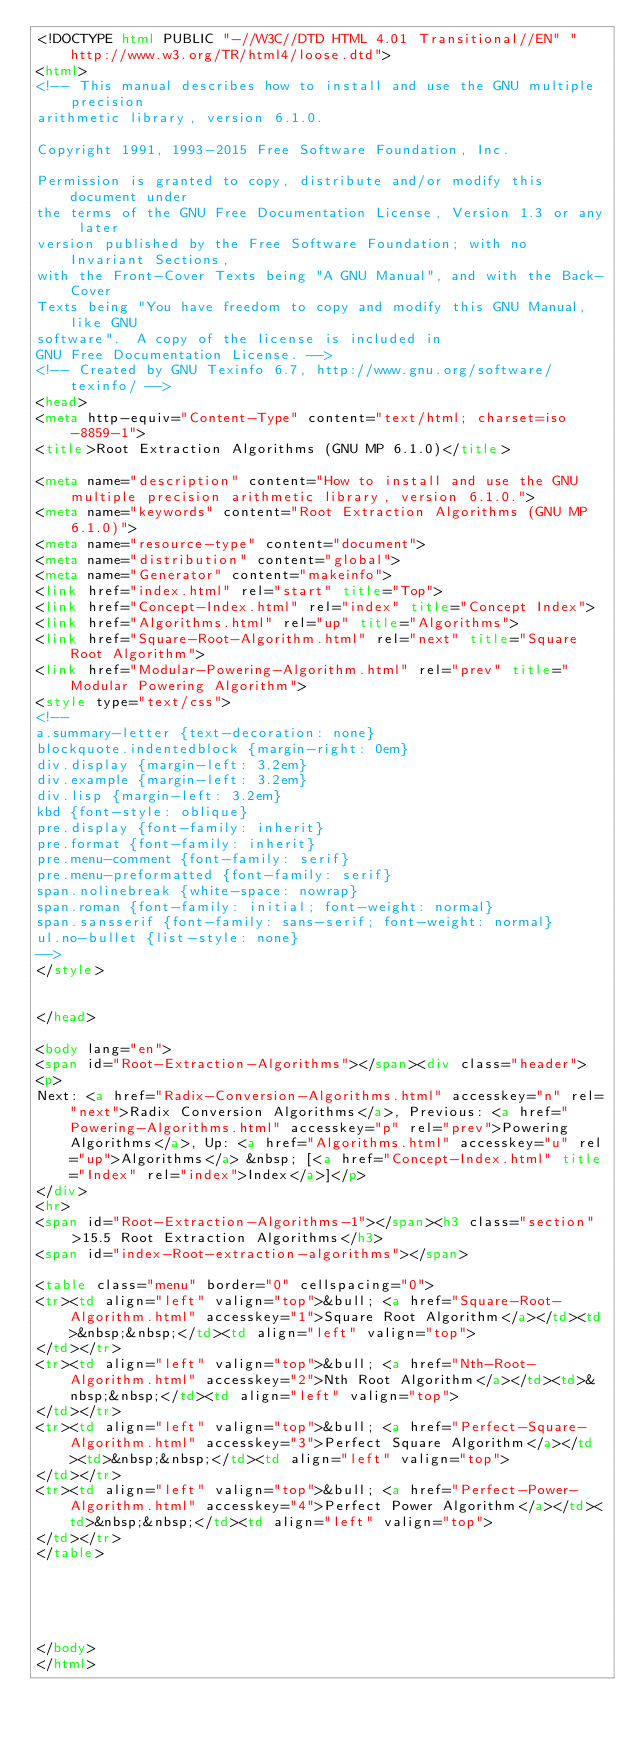<code> <loc_0><loc_0><loc_500><loc_500><_HTML_><!DOCTYPE html PUBLIC "-//W3C//DTD HTML 4.01 Transitional//EN" "http://www.w3.org/TR/html4/loose.dtd">
<html>
<!-- This manual describes how to install and use the GNU multiple precision
arithmetic library, version 6.1.0.

Copyright 1991, 1993-2015 Free Software Foundation, Inc.

Permission is granted to copy, distribute and/or modify this document under
the terms of the GNU Free Documentation License, Version 1.3 or any later
version published by the Free Software Foundation; with no Invariant Sections,
with the Front-Cover Texts being "A GNU Manual", and with the Back-Cover
Texts being "You have freedom to copy and modify this GNU Manual, like GNU
software".  A copy of the license is included in
GNU Free Documentation License. -->
<!-- Created by GNU Texinfo 6.7, http://www.gnu.org/software/texinfo/ -->
<head>
<meta http-equiv="Content-Type" content="text/html; charset=iso-8859-1">
<title>Root Extraction Algorithms (GNU MP 6.1.0)</title>

<meta name="description" content="How to install and use the GNU multiple precision arithmetic library, version 6.1.0.">
<meta name="keywords" content="Root Extraction Algorithms (GNU MP 6.1.0)">
<meta name="resource-type" content="document">
<meta name="distribution" content="global">
<meta name="Generator" content="makeinfo">
<link href="index.html" rel="start" title="Top">
<link href="Concept-Index.html" rel="index" title="Concept Index">
<link href="Algorithms.html" rel="up" title="Algorithms">
<link href="Square-Root-Algorithm.html" rel="next" title="Square Root Algorithm">
<link href="Modular-Powering-Algorithm.html" rel="prev" title="Modular Powering Algorithm">
<style type="text/css">
<!--
a.summary-letter {text-decoration: none}
blockquote.indentedblock {margin-right: 0em}
div.display {margin-left: 3.2em}
div.example {margin-left: 3.2em}
div.lisp {margin-left: 3.2em}
kbd {font-style: oblique}
pre.display {font-family: inherit}
pre.format {font-family: inherit}
pre.menu-comment {font-family: serif}
pre.menu-preformatted {font-family: serif}
span.nolinebreak {white-space: nowrap}
span.roman {font-family: initial; font-weight: normal}
span.sansserif {font-family: sans-serif; font-weight: normal}
ul.no-bullet {list-style: none}
-->
</style>


</head>

<body lang="en">
<span id="Root-Extraction-Algorithms"></span><div class="header">
<p>
Next: <a href="Radix-Conversion-Algorithms.html" accesskey="n" rel="next">Radix Conversion Algorithms</a>, Previous: <a href="Powering-Algorithms.html" accesskey="p" rel="prev">Powering Algorithms</a>, Up: <a href="Algorithms.html" accesskey="u" rel="up">Algorithms</a> &nbsp; [<a href="Concept-Index.html" title="Index" rel="index">Index</a>]</p>
</div>
<hr>
<span id="Root-Extraction-Algorithms-1"></span><h3 class="section">15.5 Root Extraction Algorithms</h3>
<span id="index-Root-extraction-algorithms"></span>

<table class="menu" border="0" cellspacing="0">
<tr><td align="left" valign="top">&bull; <a href="Square-Root-Algorithm.html" accesskey="1">Square Root Algorithm</a></td><td>&nbsp;&nbsp;</td><td align="left" valign="top">
</td></tr>
<tr><td align="left" valign="top">&bull; <a href="Nth-Root-Algorithm.html" accesskey="2">Nth Root Algorithm</a></td><td>&nbsp;&nbsp;</td><td align="left" valign="top">
</td></tr>
<tr><td align="left" valign="top">&bull; <a href="Perfect-Square-Algorithm.html" accesskey="3">Perfect Square Algorithm</a></td><td>&nbsp;&nbsp;</td><td align="left" valign="top">
</td></tr>
<tr><td align="left" valign="top">&bull; <a href="Perfect-Power-Algorithm.html" accesskey="4">Perfect Power Algorithm</a></td><td>&nbsp;&nbsp;</td><td align="left" valign="top">
</td></tr>
</table>





</body>
</html>
</code> 